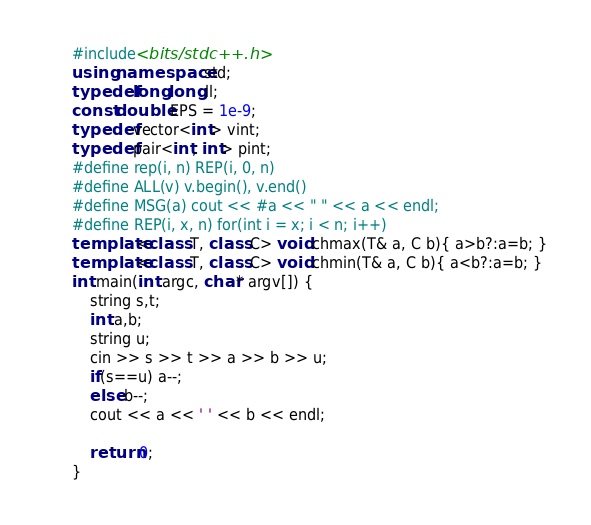<code> <loc_0><loc_0><loc_500><loc_500><_C++_>#include<bits/stdc++.h>
using namespace std;
typedef long long ll;
const double EPS = 1e-9;
typedef vector<int> vint;
typedef pair<int, int> pint;
#define rep(i, n) REP(i, 0, n)
#define ALL(v) v.begin(), v.end()
#define MSG(a) cout << #a << " " << a << endl;
#define REP(i, x, n) for(int i = x; i < n; i++)
template<class T, class C> void chmax(T& a, C b){ a>b?:a=b; }
template<class T, class C> void chmin(T& a, C b){ a<b?:a=b; }
int main(int argc, char* argv[]) {
    string s,t;
    int a,b;
    string u;
    cin >> s >> t >> a >> b >> u;
    if(s==u) a--;
    else b--;
    cout << a << ' ' << b << endl;

    return 0;
}
</code> 